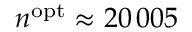<formula> <loc_0><loc_0><loc_500><loc_500>n ^ { o p t } \approx 2 0 \, 0 0 5</formula> 